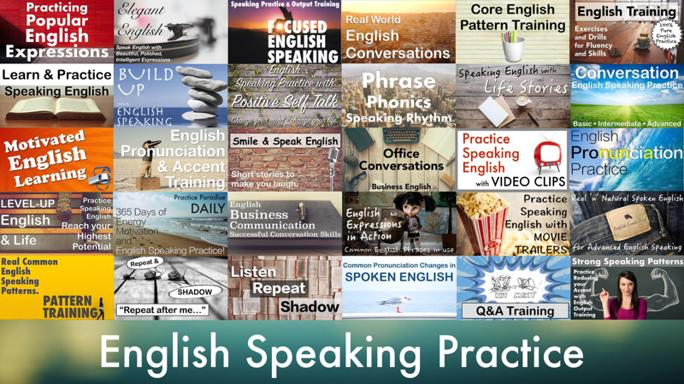Can you explain what 'shadow pattern training' mentioned in the image entails? Shadow pattern training involves learners listening to a native speaker's speech and simultaneously repeating it themselves. This method helps in mimicking the intonation, rhythm, and pronunciation patterns of fluent speakers, which is depicted in the image through the 'Listen and Repeat' strategy. 